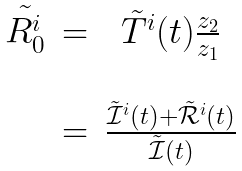Convert formula to latex. <formula><loc_0><loc_0><loc_500><loc_500>\begin{array} { c c c } \tilde { R _ { 0 } ^ { i } } & = & \tilde { T } ^ { i } ( t ) \frac { z _ { 2 } } { z _ { 1 } } \\ \\ & = & \frac { \tilde { \mathcal { I } } ^ { i } ( t ) + \tilde { \mathcal { R } } ^ { i } ( t ) } { \tilde { \mathcal { I } } ( t ) } \end{array}</formula> 